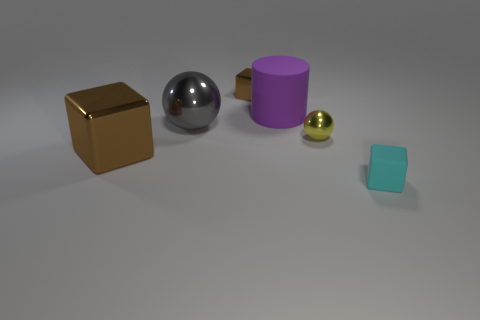There is a small cyan matte thing; what shape is it?
Give a very brief answer. Cube. Is the large metallic sphere the same color as the tiny matte cube?
Provide a short and direct response. No. There is a cylinder that is the same size as the gray thing; what is its color?
Your response must be concise. Purple. What number of cyan things are either tiny things or large rubber things?
Offer a very short reply. 1. Is the number of small yellow shiny blocks greater than the number of tiny matte cubes?
Your response must be concise. No. There is a metallic block behind the small yellow object; is it the same size as the matte object left of the cyan object?
Ensure brevity in your answer.  No. There is a matte thing that is behind the cube to the left of the tiny cube that is behind the large brown metallic thing; what color is it?
Your answer should be very brief. Purple. Is there a brown metal object that has the same shape as the gray thing?
Keep it short and to the point. No. Are there more tiny cyan blocks that are behind the gray sphere than small purple metallic cubes?
Ensure brevity in your answer.  No. What number of metallic objects are tiny cubes or large blocks?
Your answer should be very brief. 2. 